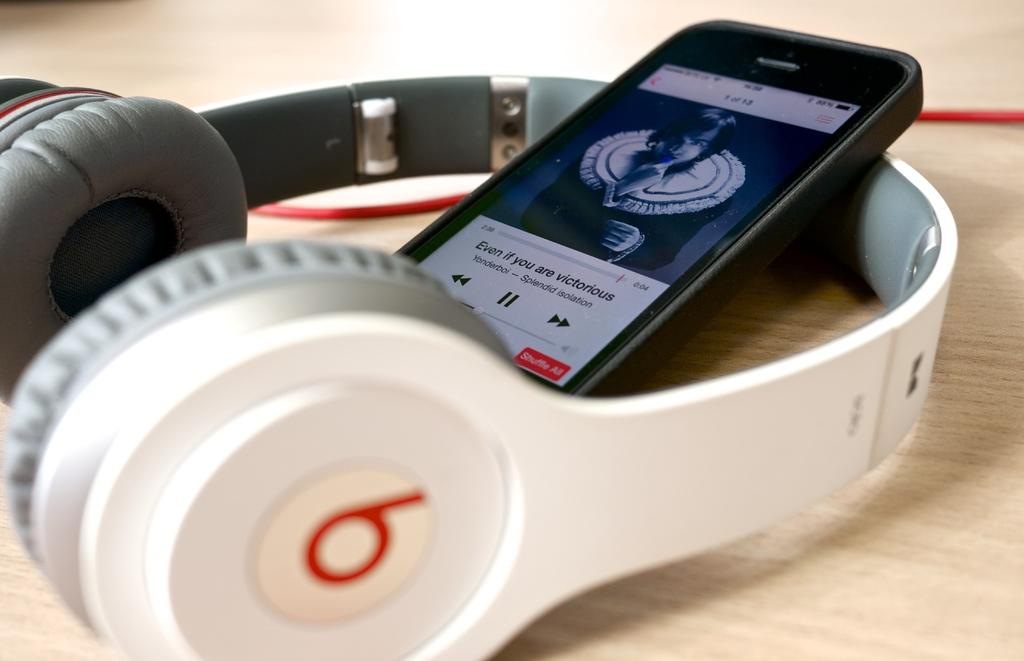What is the main object in the image? There is a mobile in the image. Where is the mobile located? The mobile is placed on a headset. What is the headset resting on? The headset is on a table. What type of quilt is draped over the trees in the image? There are no trees or quilts present in the image; it only features a mobile on a headset on a table. 